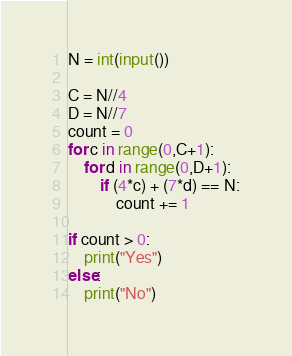Convert code to text. <code><loc_0><loc_0><loc_500><loc_500><_Python_>N = int(input())

C = N//4
D = N//7
count = 0
for c in range(0,C+1):
    for d in range(0,D+1):
        if (4*c) + (7*d) == N:
            count += 1

if count > 0:
    print("Yes")
else:
    print("No")</code> 